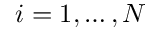Convert formula to latex. <formula><loc_0><loc_0><loc_500><loc_500>i = 1 , \dots , N</formula> 